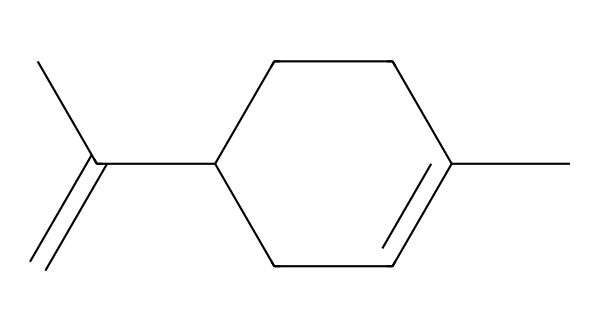What is the molecular formula of limonene? To find the molecular formula, count the carbon (C) and hydrogen (H) atoms in the given structure. There are 10 carbon atoms and 16 hydrogen atoms. Therefore, the molecular formula is C10H16.
Answer: C10H16 How many chiral centers are in limonene? By examining the structural representation, look for carbon atoms that are attached to four different substituents. There is one carbon atom fulfilling this condition, indicating that there is one chiral center.
Answer: 1 What is one common use of limonene? Limonene is commonly used as a fragrance in cleaning products, providing a citrus scent. This is a direct application of its pleasant smell.
Answer: fragrance What types of isomers does limonene have? Limonene has two structural isomers known as L-limonene and D-limonene, which are enantiomers due to the presence of a chiral center. These isomers have similar physical properties but differ in their optical activity.
Answer: enantiomers What type of compound is limonene classified as? Given the structure, limonene is a type of terpene, which is a compound built from isoprene units and characterized by the presence of double bonds and a chiral center, typical of such compounds.
Answer: terpene What is the significance of the double bond in limonene? The double bond in limonene contributes to its reactivity and influences its fragrance properties. Double bonds are essential for the stability and reactivity of the molecule, affecting how it interacts in different environments.
Answer: reactivity 